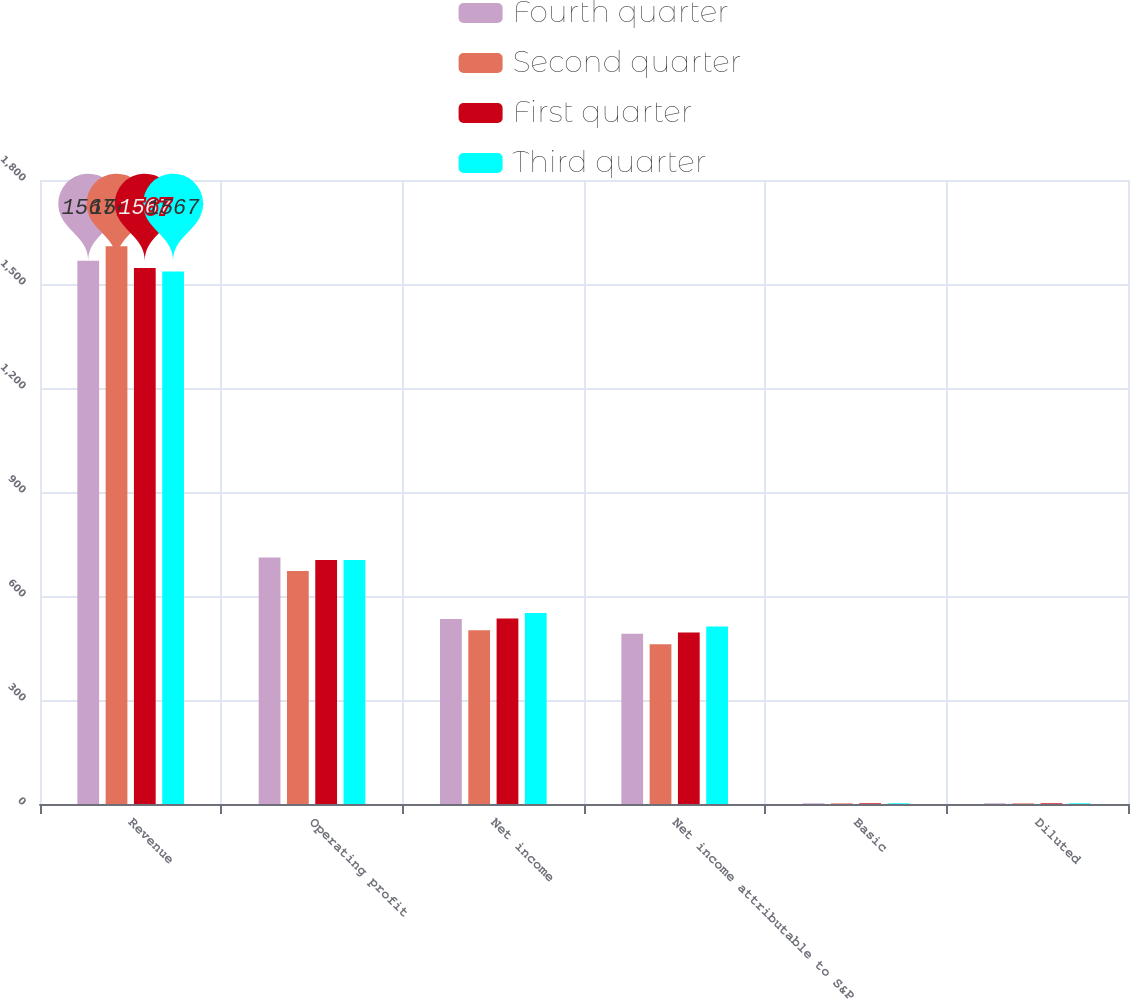<chart> <loc_0><loc_0><loc_500><loc_500><stacked_bar_chart><ecel><fcel>Revenue<fcel>Operating profit<fcel>Net income<fcel>Net income attributable to S&P<fcel>Basic<fcel>Diluted<nl><fcel>Fourth quarter<fcel>1567<fcel>711<fcel>534<fcel>491<fcel>1.94<fcel>1.93<nl><fcel>Second quarter<fcel>1609<fcel>672<fcel>501<fcel>461<fcel>1.83<fcel>1.82<nl><fcel>First quarter<fcel>1546<fcel>704<fcel>535<fcel>495<fcel>1.97<fcel>1.95<nl><fcel>Third quarter<fcel>1536<fcel>704<fcel>551<fcel>512<fcel>2.06<fcel>2.03<nl></chart> 